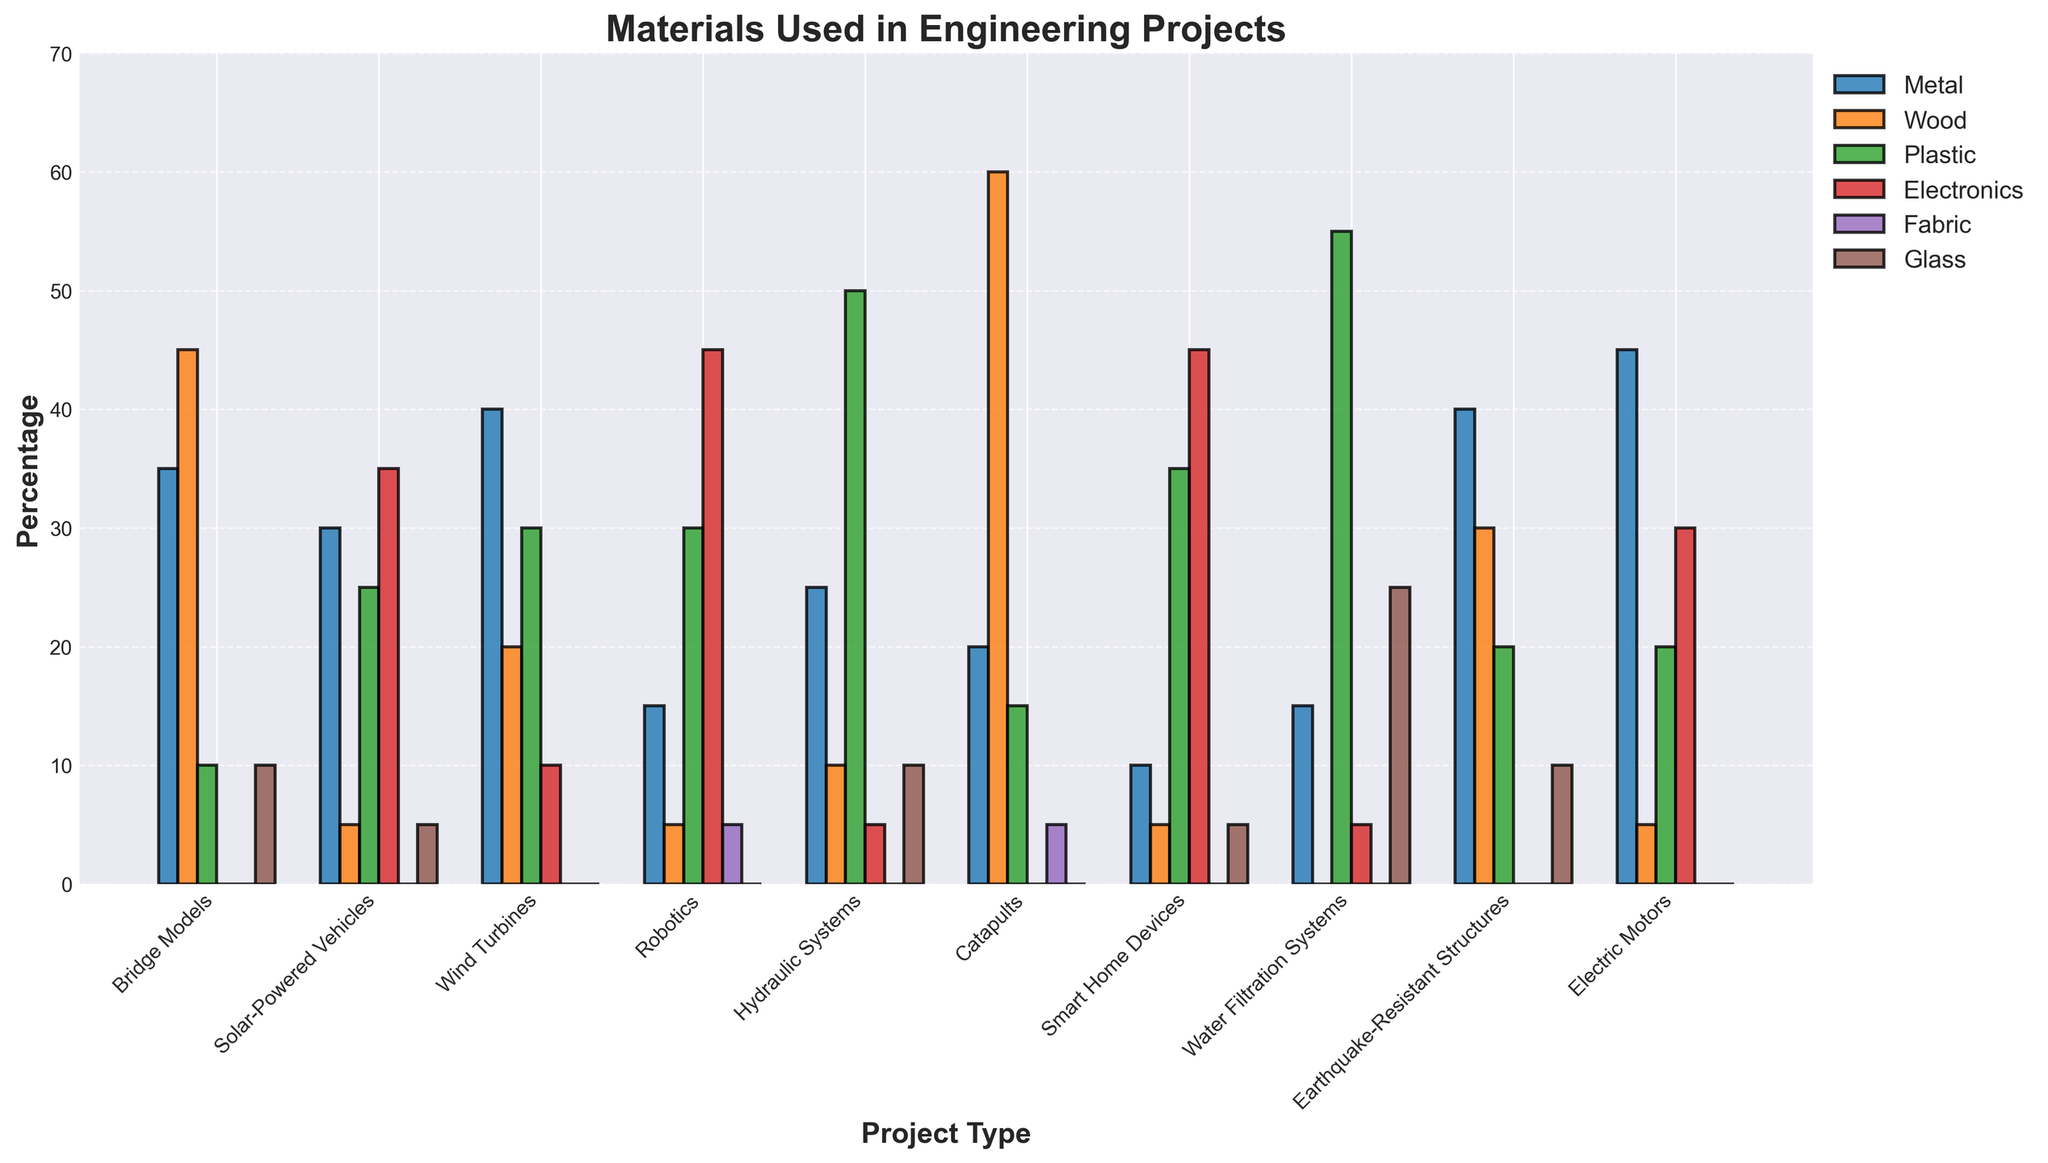What is the most common material used for building robotic projects? Look at the "Robotics" project type and identify the tallest bar. The tallest bar for Robotics is Electronics.
Answer: Electronics Which project type uses the least amount of wood? Compare the height of the Wood bar across all project types and identify the shortest one. The "Water Filtration Systems" project type has no wood represented, making it the least.
Answer: Water Filtration Systems What material is used the most in Solar-Powered Vehicles, and how does it compare to the same material used in Smart Home Devices? Identify the tallest bar for "Solar-Powered Vehicles" which is Electronics. Then, compare it with the height of the Electronics bar in "Smart Home Devices," which is equal.
Answer: Electronics, equally used Which materials are used exactly 5 times in different projects, and in which project types do they appear? Identify the bars with a height of 5. The materials are Wood in "Solar-Powered Vehicles," "Robotics," "Smart Home Devices," Fabric in "Catapults," and Electronics in "Hydraulic Systems".
Answer: Wood (Solar-Powered Vehicles, Robotics, Smart Home Devices), Fabric (Catapults), Electronics (Hydraulic Systems) Which project type uses the most diverse range of materials? Compare the number of different materials (i.e., non-zero bars) used in each project type. "Solar-Powered Vehicles" and "Water Filtration Systems" have the most diverse range with 5 different materials each.
Answer: Solar-Powered Vehicles, Water Filtration Systems What is the total percentage of Plastic used across all projects? Sum the heights of the Plastic bars across all project types. The values are 10 (Bridge Models) + 25 (Solar-Powered Vehicles) + 30 (Wind Turbines) + 30 (Robotics) + 50 (Hydraulic Systems) + 15 (Catapults) + 35 (Smart Home Devices) + 55 (Water Filtration Systems) + 20 (Earthquake-Resistant Structures) + 20 (Electric Motors) = 290.
Answer: 290 Considering Metals and Electronics in both Bridge Models and Wind Turbines, which one has the highest combined usage? Sum the heights of Metal and Electronics for "Bridge Models" and "Wind Turbines." For Bridge Models: 35 (Metal) + 0 (Electronics) = 35. For Wind Turbines: 40 (Metal) + 10 (Electronics) = 50. Wind Turbines have a higher combined usage.
Answer: Wind Turbines 